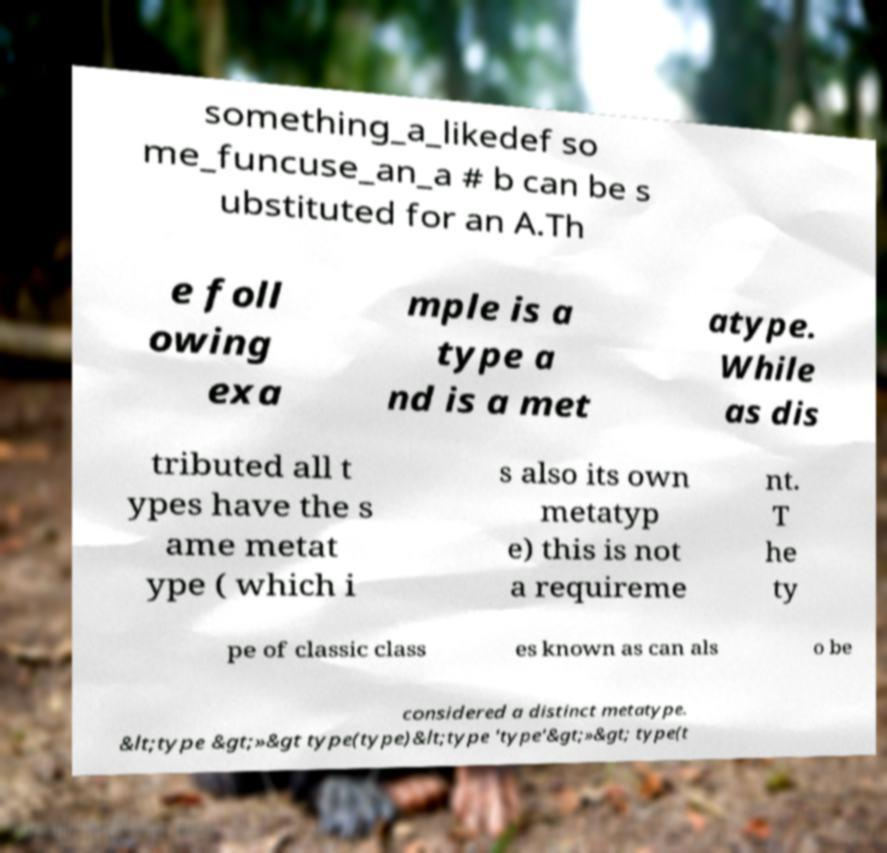What messages or text are displayed in this image? I need them in a readable, typed format. something_a_likedef so me_funcuse_an_a # b can be s ubstituted for an A.Th e foll owing exa mple is a type a nd is a met atype. While as dis tributed all t ypes have the s ame metat ype ( which i s also its own metatyp e) this is not a requireme nt. T he ty pe of classic class es known as can als o be considered a distinct metatype. &lt;type &gt;»&gt type(type)&lt;type 'type'&gt;»&gt; type(t 